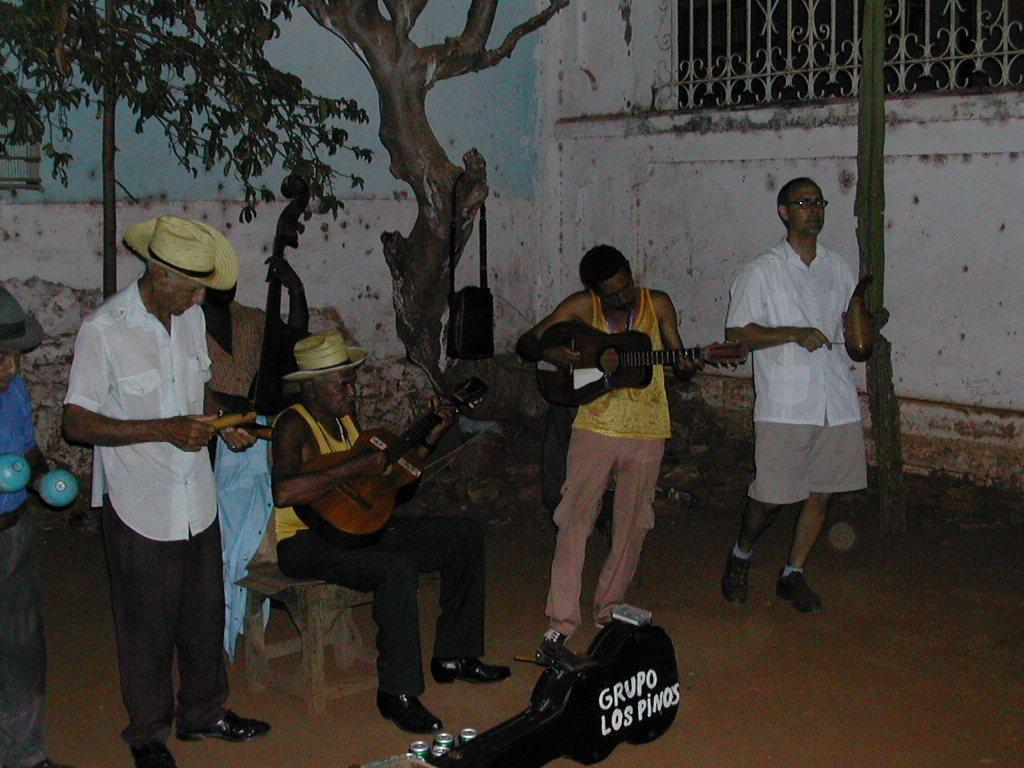Describe this image in one or two sentences. In the foreground of the image, there are four persons are standing and playing musical instruments and one person is sitting on the chair and playing musical instrument as guitar. In the background wall is visible of white and blue in color and a window is visible. In the middle, a tree is visible. This image is taken outside the house. 